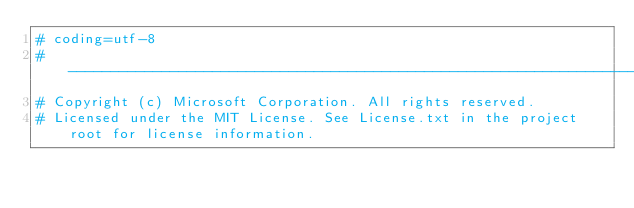<code> <loc_0><loc_0><loc_500><loc_500><_Python_># coding=utf-8
# --------------------------------------------------------------------------
# Copyright (c) Microsoft Corporation. All rights reserved.
# Licensed under the MIT License. See License.txt in the project root for license information.</code> 